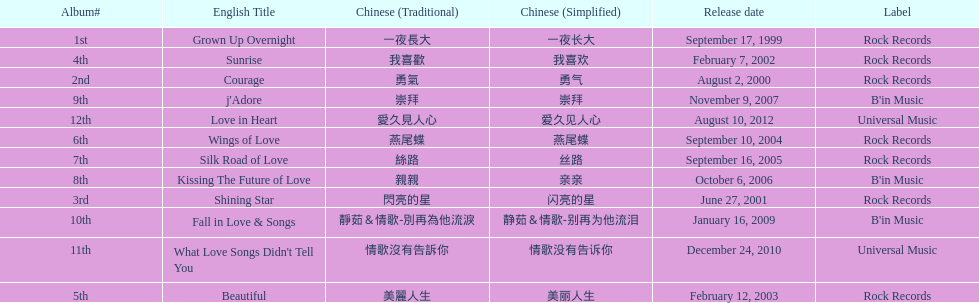Was the album beautiful released before the album love in heart? Yes. 